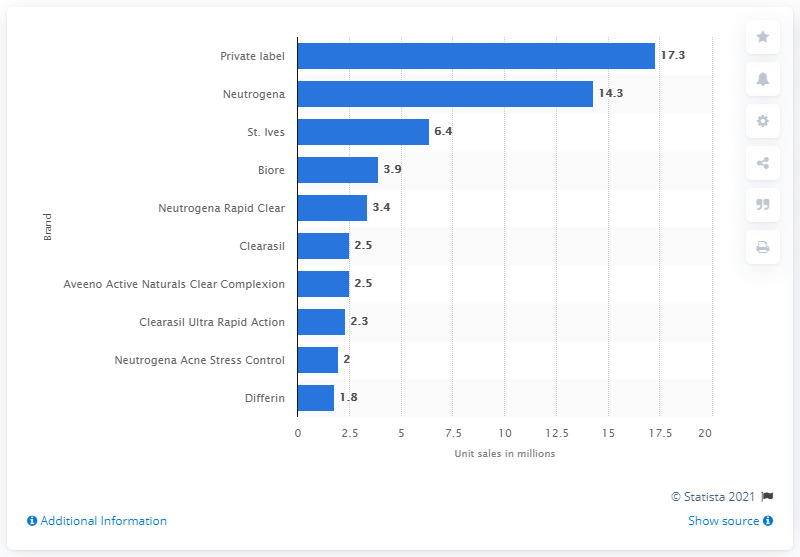Indicate a few pertinent items in this graphic. In 2018, Neutrogena had unit sales of approximately 14.3 million for their acne treatment brand. Neutrogena's unit sales in 2018 were 14.3... 